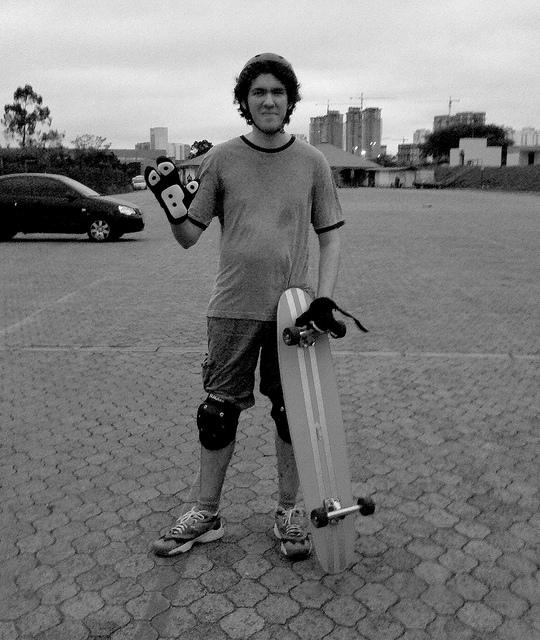Was this taken inside?
Keep it brief. No. Is he a champion?
Concise answer only. No. Is there any color in this picture?
Give a very brief answer. No. Is there a fence?
Concise answer only. No. Which direction is the boy looking?
Answer briefly. North. What are on the man's lower legs?
Answer briefly. Knee pads. Is the man running wearing sunglasses?
Be succinct. No. Are two of these people blurry because they have been photoshopped into the picture?
Be succinct. No. 